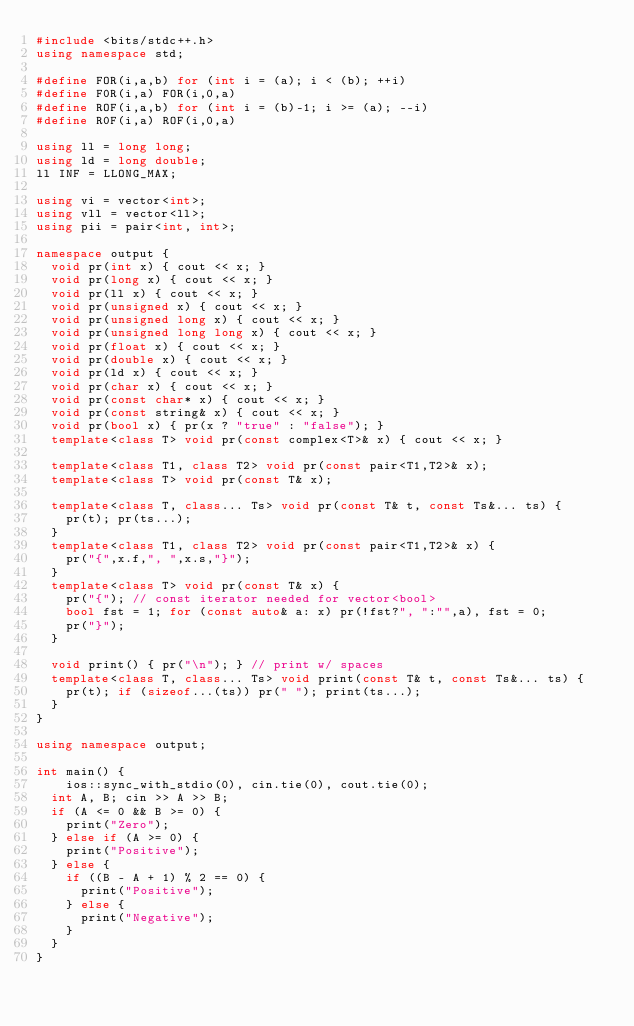<code> <loc_0><loc_0><loc_500><loc_500><_C++_>#include <bits/stdc++.h>
using namespace std;

#define FOR(i,a,b) for (int i = (a); i < (b); ++i)
#define F0R(i,a) FOR(i,0,a)
#define ROF(i,a,b) for (int i = (b)-1; i >= (a); --i)
#define R0F(i,a) ROF(i,0,a)

using ll = long long;
using ld = long double;
ll INF = LLONG_MAX;

using vi = vector<int>;
using vll = vector<ll>;
using pii = pair<int, int>;

namespace output {
	void pr(int x) { cout << x; }
	void pr(long x) { cout << x; }
	void pr(ll x) { cout << x; }
	void pr(unsigned x) { cout << x; }
	void pr(unsigned long x) { cout << x; }
	void pr(unsigned long long x) { cout << x; }
	void pr(float x) { cout << x; }
	void pr(double x) { cout << x; }
	void pr(ld x) { cout << x; }
	void pr(char x) { cout << x; }
	void pr(const char* x) { cout << x; }
	void pr(const string& x) { cout << x; }
	void pr(bool x) { pr(x ? "true" : "false"); }
	template<class T> void pr(const complex<T>& x) { cout << x; }
	
	template<class T1, class T2> void pr(const pair<T1,T2>& x);
	template<class T> void pr(const T& x);
	
	template<class T, class... Ts> void pr(const T& t, const Ts&... ts) { 
		pr(t); pr(ts...); 
	}
	template<class T1, class T2> void pr(const pair<T1,T2>& x) { 
		pr("{",x.f,", ",x.s,"}"); 
	}
	template<class T> void pr(const T& x) { 
		pr("{"); // const iterator needed for vector<bool>
		bool fst = 1; for (const auto& a: x) pr(!fst?", ":"",a), fst = 0; 
		pr("}");
	}
	
	void print() { pr("\n"); } // print w/ spaces
	template<class T, class... Ts> void print(const T& t, const Ts&... ts) { 
		pr(t); if (sizeof...(ts)) pr(" "); print(ts...); 
	}
}

using namespace output;

int main() {
    ios::sync_with_stdio(0), cin.tie(0), cout.tie(0);
	int A, B; cin >> A >> B;
	if (A <= 0 && B >= 0) {
		print("Zero");
	} else if (A >= 0) {
		print("Positive");
	} else {
		if ((B - A + 1) % 2 == 0) {
			print("Positive");
		} else {
			print("Negative");
		}
	}
}</code> 